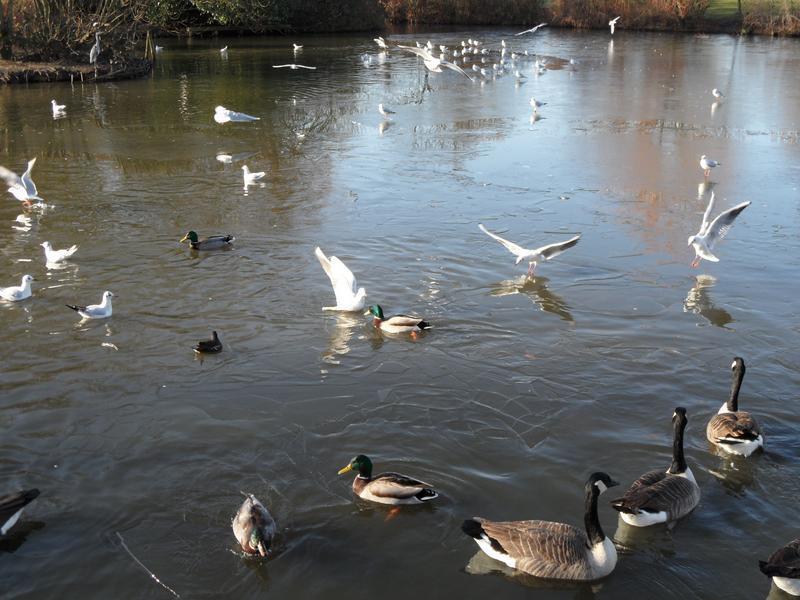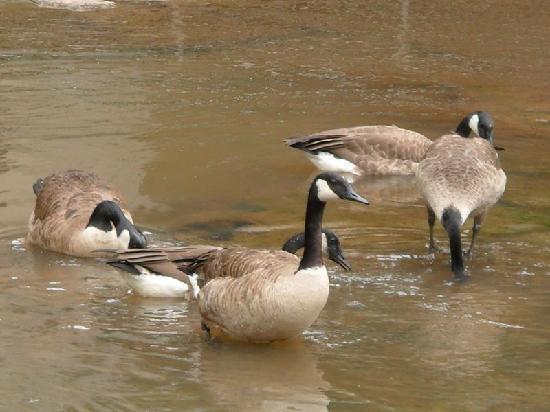The first image is the image on the left, the second image is the image on the right. For the images displayed, is the sentence "There are geese visible on the water" factually correct? Answer yes or no. Yes. 